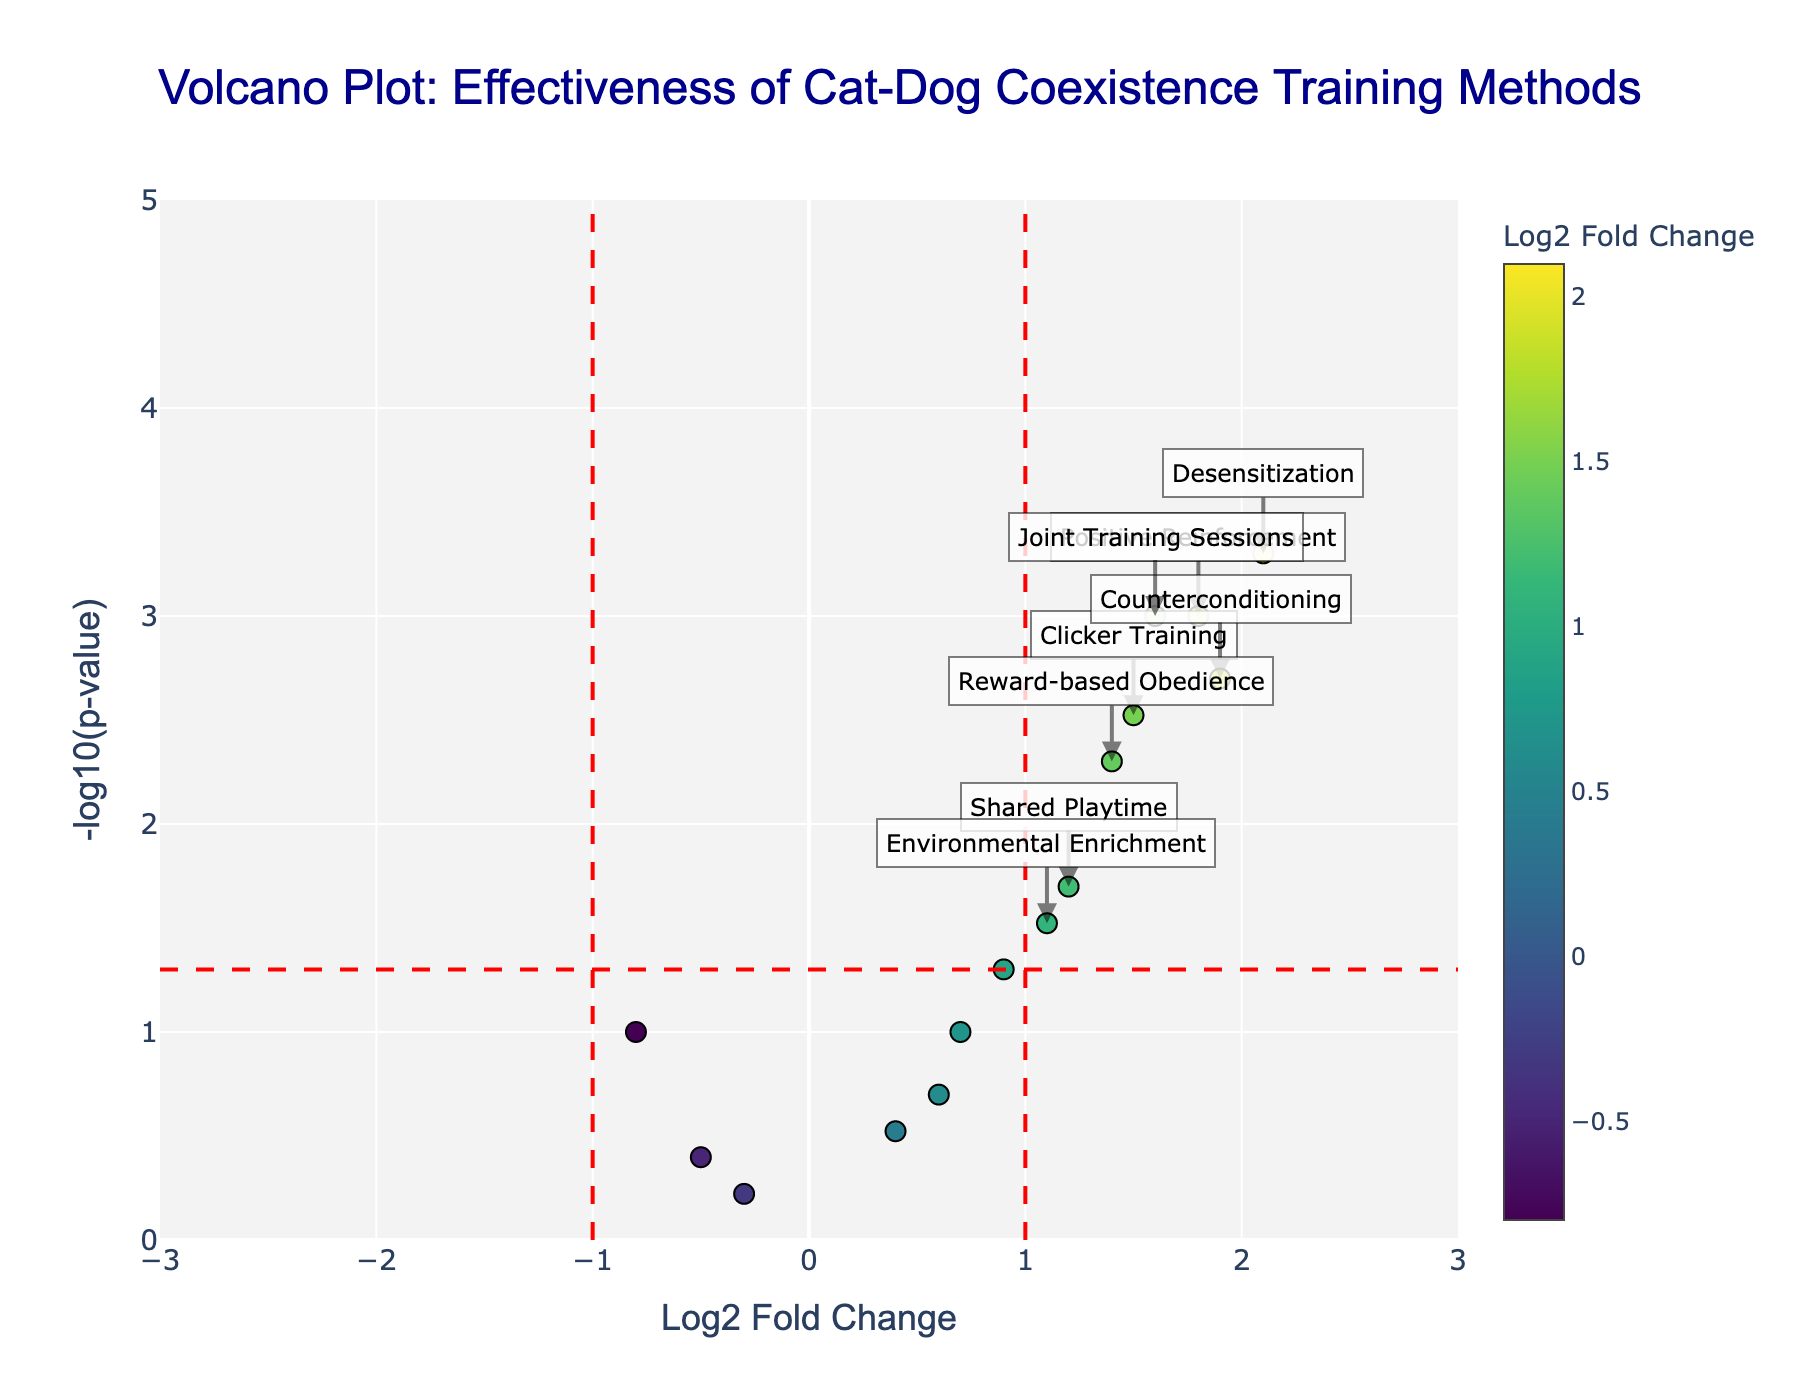What is the title of the plot? The title is displayed at the top center of the plot in large, dark blue font. It reads "Volcano Plot: Effectiveness of Cat-Dog Coexistence Training Methods."
Answer: Volcano Plot: Effectiveness of Cat-Dog Coexistence Training Methods What do the x-axis and y-axis represent? The x-axis represents the log2 fold change, which measures the effectiveness of different training methods on cat-dog coexistence. The y-axis represents the negative log10 of the p-value, which shows the significance of the results.
Answer: Log2 fold change and -log10(p-value) What color is associated with the highest log2 fold change values? The colors range from green to yellow to blue, but for the highest log2 fold change values, the color tends to be darker (towards more saturation). Therefore, dark blue hues are associated with higher values.
Answer: Dark blue How many methods have a log2 fold change greater than 1 and a p-value less than 0.05? To determine this, we look at the points that are to the right of the red vertical line at log2 fold change = 1 and above the red horizontal line that represents p-value = 0.05. These points represent significant methods: Positive Reinforcement, Desensitization, Counterconditioning, Joint Training Sessions, and Reward-based Obedience.
Answer: 5 methods Which method has the highest significance (lowest p-value)? The method with the highest significance is the one with the largest value on the y-axis (-log10(p-value)). This is represented by Desensitization, which has the highest y-axis value.
Answer: Desensitization Which methods have a negative log2 fold change but are not significant? Negative log2 fold changes correspond to the left side of the plot, and non-significant results are those under the red horizontal line for p-value > 0.05. These methods are Controlled Introduction, Separate Spaces, and Time-outs.
Answer: Controlled Introduction, Separate Spaces, Time-outs Among the significant methods, which one has the smallest log2 fold change? Among the significant methods, Positive Reinforcement, Clicker Training, Desensitization, Counterconditioning, Joint Training Sessions, and Reward-based Obedience, the one with the smallest log2 fold change is Clicker Training.
Answer: Clicker Training How does the y-axis value of Environmental Enrichment compare to Shared Playtime? To compare their y-axis values, we find their -log10(p-value) on the plot. Environmental Enrichment has a y-axis value of about -log10(0.03) ≈ 1.52, while Shared Playtime has a y-axis value of about -log10(0.02) ≈ 1.70. Shared Playtime is higher.
Answer: Shared Playtime is higher What threshold lines are included in the plot, and what do they represent? The plot includes three red dashed threshold lines. The vertical lines at log2 fold change = 1 and -1 represent the significance threshold for fold change, and the horizontal line at -log10(p-value) ≈ 1.30 represents the threshold for p-value significance (0.05).
Answer: Log2 fold change = 1, -1, and -log10(p-value) = 1.30 